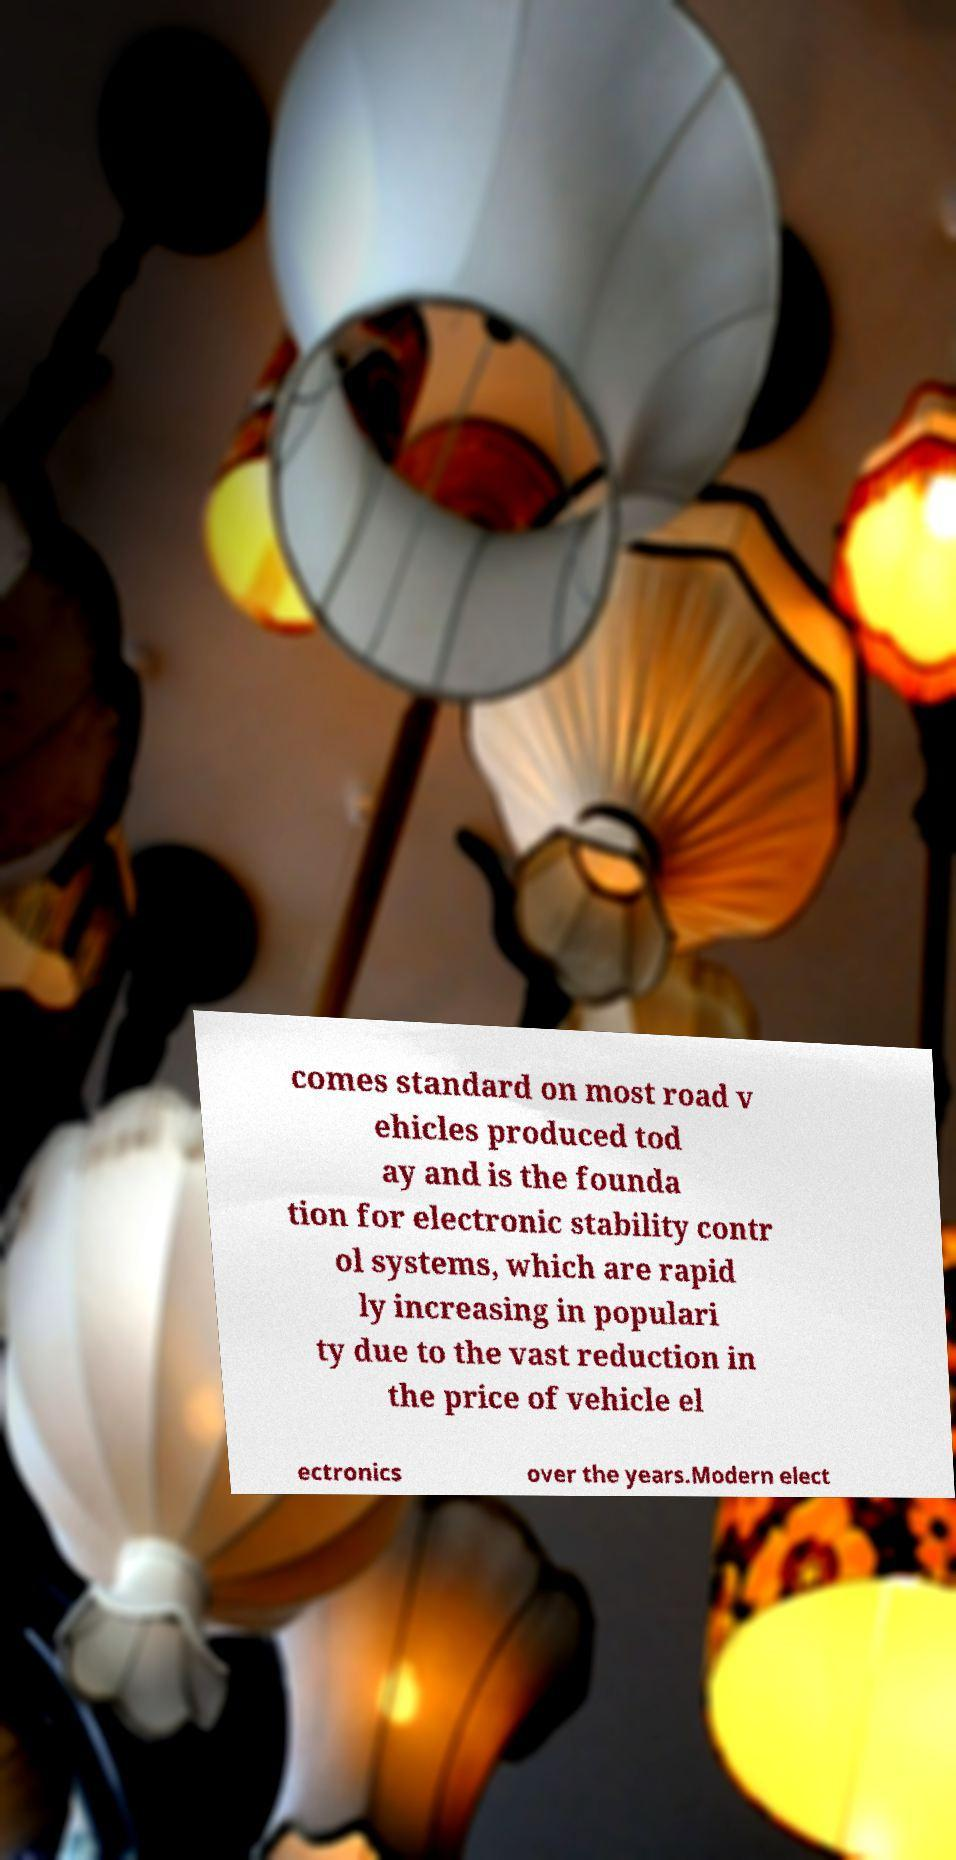Can you read and provide the text displayed in the image?This photo seems to have some interesting text. Can you extract and type it out for me? comes standard on most road v ehicles produced tod ay and is the founda tion for electronic stability contr ol systems, which are rapid ly increasing in populari ty due to the vast reduction in the price of vehicle el ectronics over the years.Modern elect 